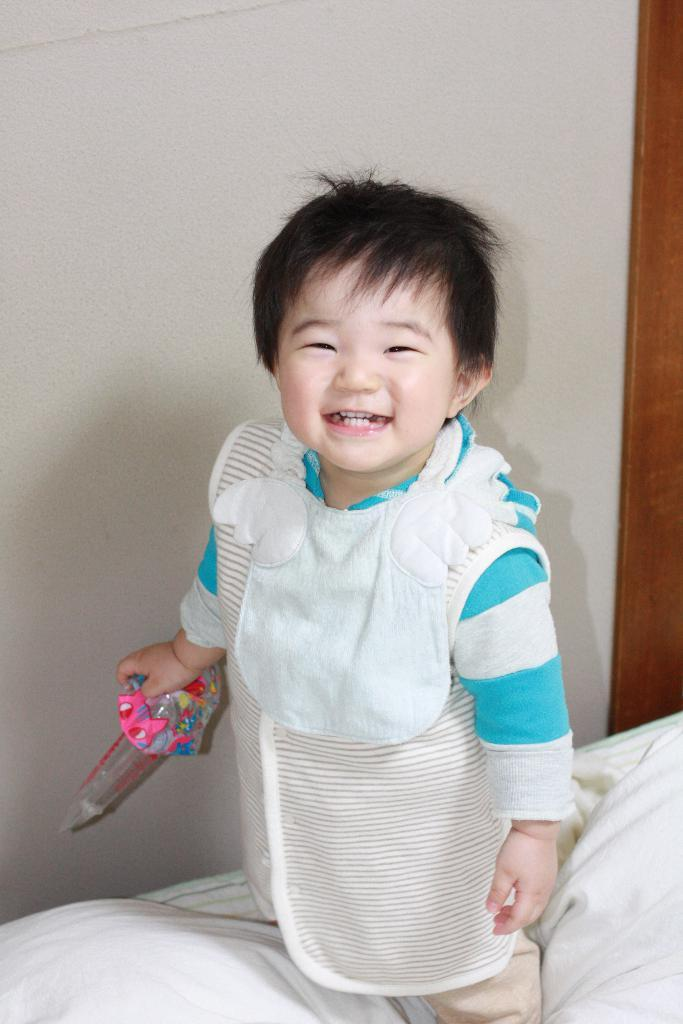What is the main subject of the image? The main subject of the image is a kid. What is the kid holding in the image? The kid is holding a toy. Where is the kid standing in the image? The kid is standing on a blanket. What is the blanket placed on in the image? The blanket is on a bed. What can be seen in the background of the image? There is a wall in the background of the image. What type of plant is growing on the wall in the image? There is no plant growing on the wall in the image; it only features a wall in the background. 